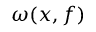Convert formula to latex. <formula><loc_0><loc_0><loc_500><loc_500>\omega ( x , f )</formula> 